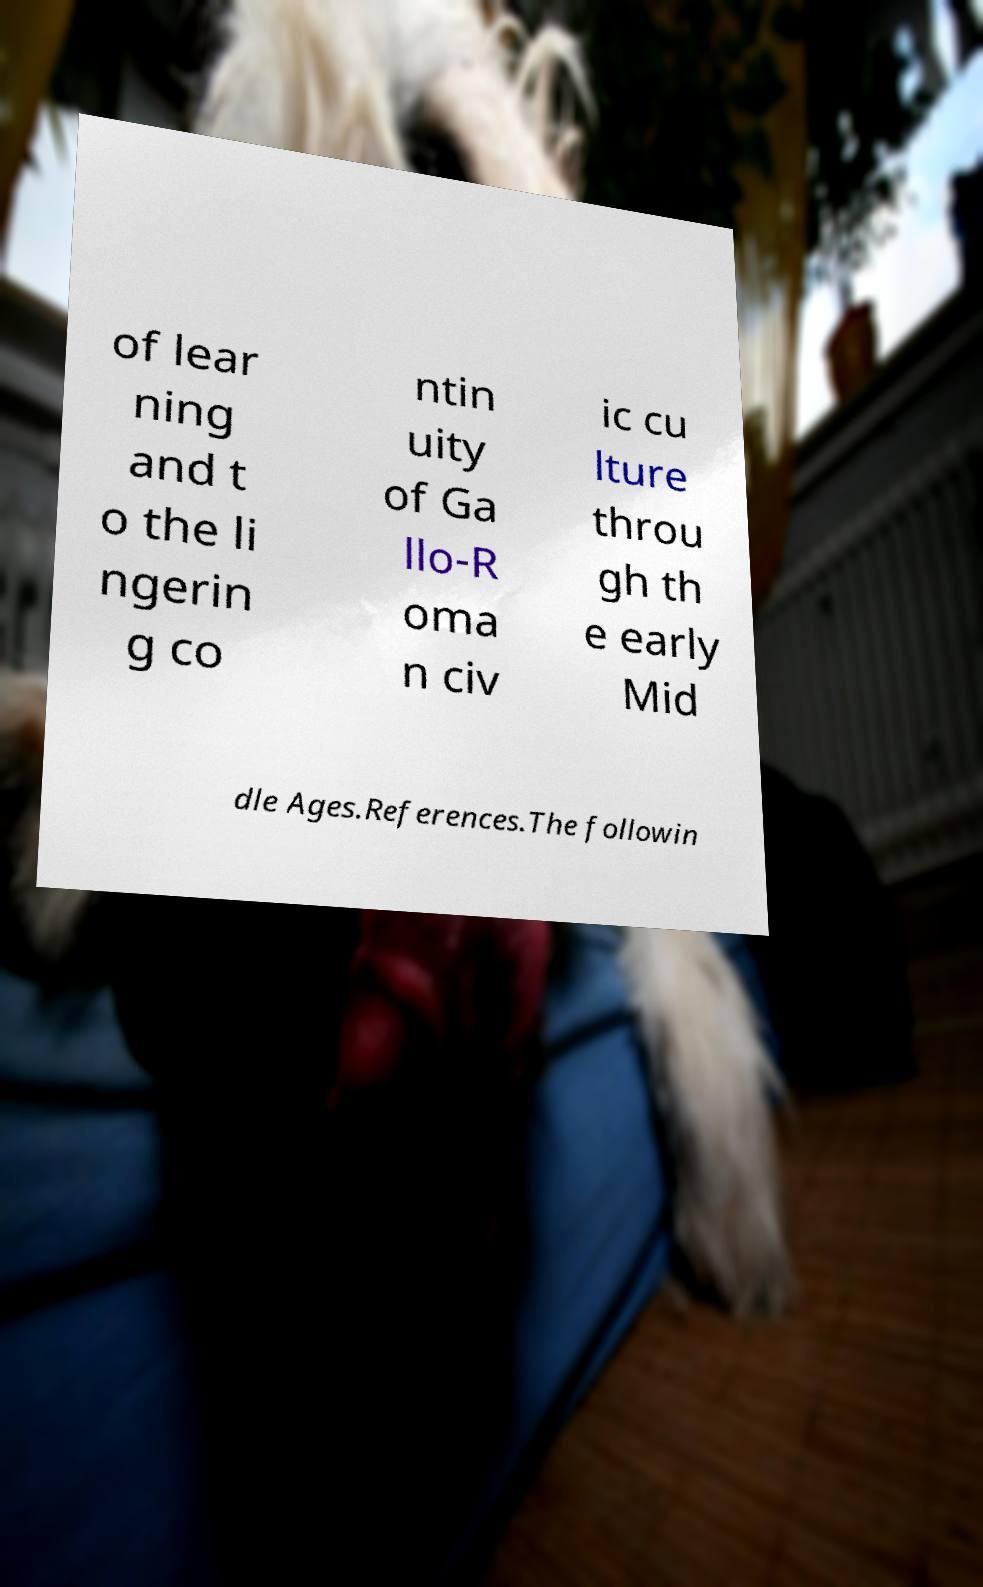Please identify and transcribe the text found in this image. of lear ning and t o the li ngerin g co ntin uity of Ga llo-R oma n civ ic cu lture throu gh th e early Mid dle Ages.References.The followin 